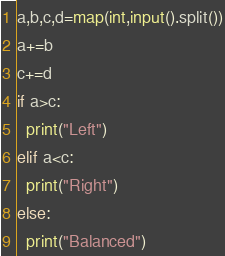<code> <loc_0><loc_0><loc_500><loc_500><_Python_>a,b,c,d=map(int,input().split())
a+=b
c+=d
if a>c:
  print("Left")
elif a<c:
  print("Right")
else:
  print("Balanced")</code> 